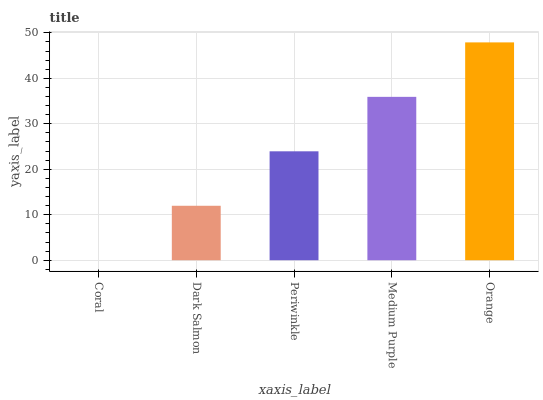Is Coral the minimum?
Answer yes or no. Yes. Is Orange the maximum?
Answer yes or no. Yes. Is Dark Salmon the minimum?
Answer yes or no. No. Is Dark Salmon the maximum?
Answer yes or no. No. Is Dark Salmon greater than Coral?
Answer yes or no. Yes. Is Coral less than Dark Salmon?
Answer yes or no. Yes. Is Coral greater than Dark Salmon?
Answer yes or no. No. Is Dark Salmon less than Coral?
Answer yes or no. No. Is Periwinkle the high median?
Answer yes or no. Yes. Is Periwinkle the low median?
Answer yes or no. Yes. Is Coral the high median?
Answer yes or no. No. Is Medium Purple the low median?
Answer yes or no. No. 